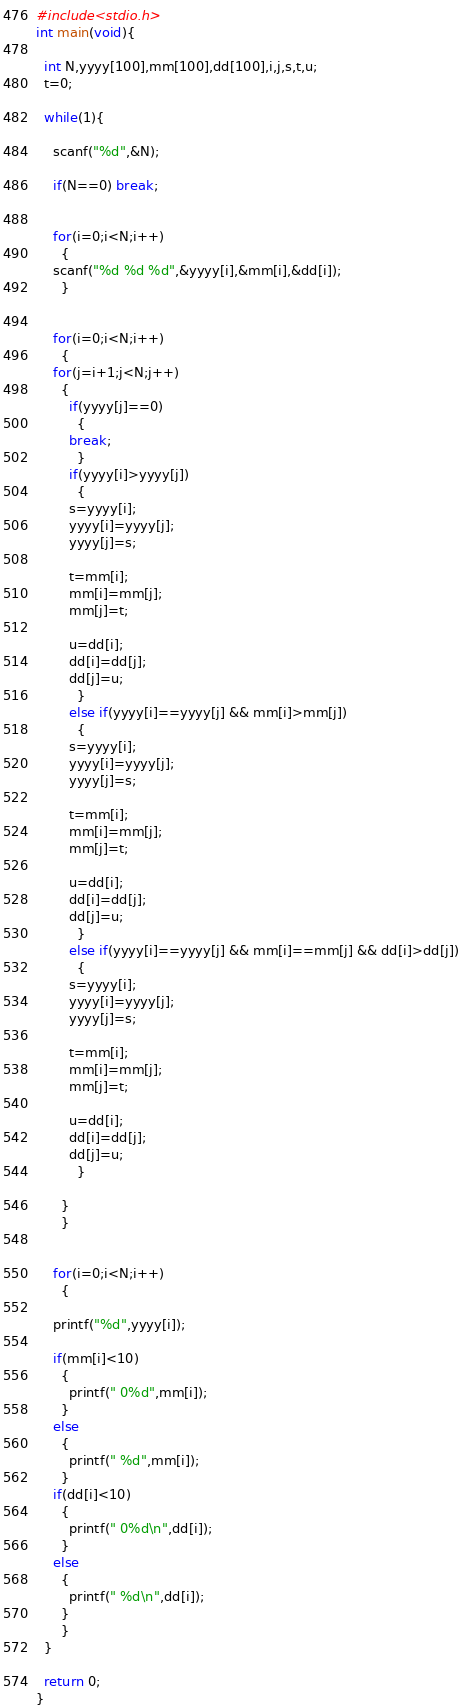Convert code to text. <code><loc_0><loc_0><loc_500><loc_500><_C_>#include<stdio.h>
int main(void){
  
  int N,yyyy[100],mm[100],dd[100],i,j,s,t,u;
  t=0;
  
  while(1){
    
    scanf("%d",&N);
    
    if(N==0) break;
    
    
    for(i=0;i<N;i++)
      {
	scanf("%d %d %d",&yyyy[i],&mm[i],&dd[i]);
      }
    
    
    for(i=0;i<N;i++)
      {
	for(j=i+1;j<N;j++)
	  {
	    if(yyyy[j]==0)
	      {
		break;
	      }
	    if(yyyy[i]>yyyy[j])
	      {
		s=yyyy[i];
		yyyy[i]=yyyy[j];
		yyyy[j]=s;
		
		t=mm[i];
		mm[i]=mm[j];
		mm[j]=t;
		
		u=dd[i];
		dd[i]=dd[j];
		dd[j]=u;
	      }
	    else if(yyyy[i]==yyyy[j] && mm[i]>mm[j])
	      {
		s=yyyy[i];
		yyyy[i]=yyyy[j];
		yyyy[j]=s;
		
		t=mm[i];
		mm[i]=mm[j];
		mm[j]=t;
		
		u=dd[i];
		dd[i]=dd[j];
		dd[j]=u;
	      }
	    else if(yyyy[i]==yyyy[j] && mm[i]==mm[j] && dd[i]>dd[j])
	      {
		s=yyyy[i];
		yyyy[i]=yyyy[j];
		yyyy[j]=s;
		
		t=mm[i];
		mm[i]=mm[j];
		mm[j]=t;
		
		u=dd[i];
		dd[i]=dd[j];
		dd[j]=u;
	      }
	    
	  } 
      }
    
    
    for(i=0;i<N;i++)
      {
	
	printf("%d",yyyy[i]);
	
	if(mm[i]<10)
	  {
	    printf(" 0%d",mm[i]);
	  }
	else
	  {
	    printf(" %d",mm[i]);
	  }
	if(dd[i]<10)
	  {
	    printf(" 0%d\n",dd[i]);
	  }
	else
	  {
	    printf(" %d\n",dd[i]);
	  }
      }
  }
  
  return 0;
}</code> 